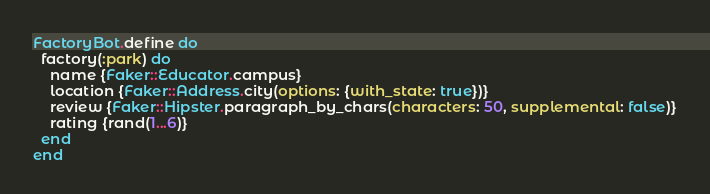<code> <loc_0><loc_0><loc_500><loc_500><_Ruby_>FactoryBot.define do
  factory(:park) do
    name {Faker::Educator.campus}
    location {Faker::Address.city(options: {with_state: true})}
    review {Faker::Hipster.paragraph_by_chars(characters: 50, supplemental: false)}
    rating {rand(1...6)}
  end
end</code> 